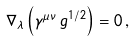<formula> <loc_0><loc_0><loc_500><loc_500>\nabla _ { \lambda } \left ( \gamma ^ { \mu \nu } \, g ^ { 1 / 2 } \right ) = 0 \, ,</formula> 